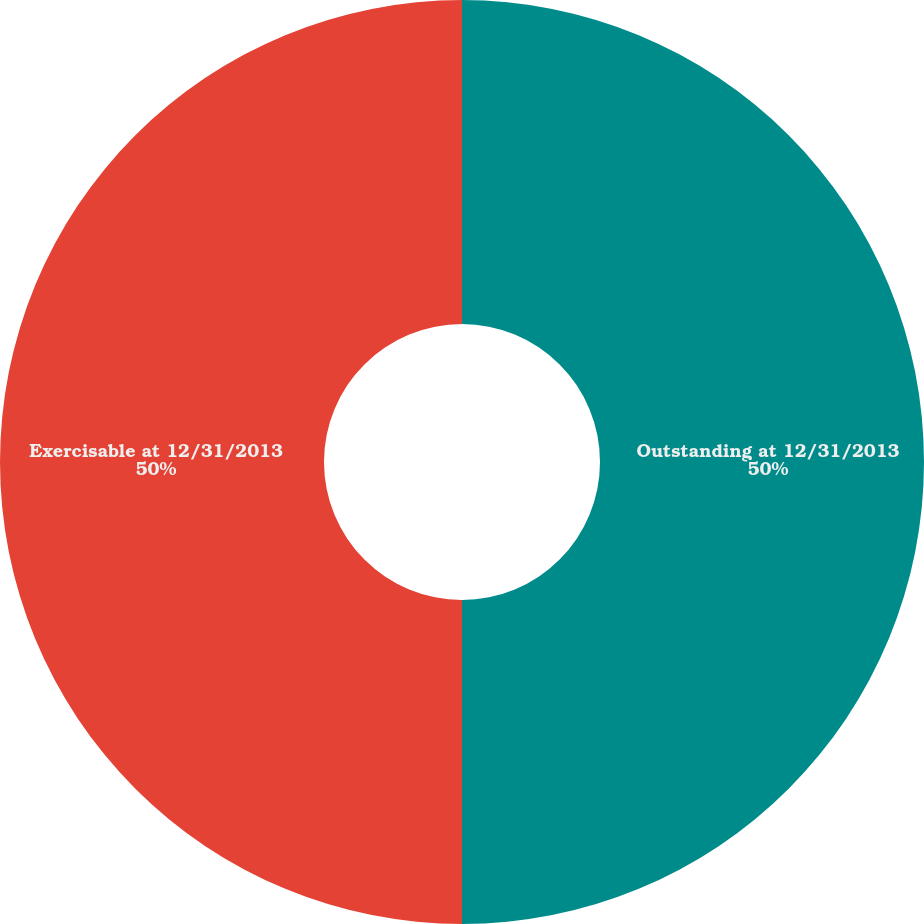Convert chart to OTSL. <chart><loc_0><loc_0><loc_500><loc_500><pie_chart><fcel>Outstanding at 12/31/2013<fcel>Exercisable at 12/31/2013<nl><fcel>50.0%<fcel>50.0%<nl></chart> 